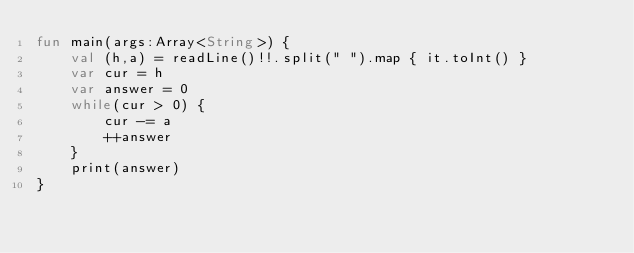Convert code to text. <code><loc_0><loc_0><loc_500><loc_500><_Kotlin_>fun main(args:Array<String>) {
    val (h,a) = readLine()!!.split(" ").map { it.toInt() }
    var cur = h
    var answer = 0
    while(cur > 0) {
        cur -= a
        ++answer
    }
    print(answer)
}</code> 